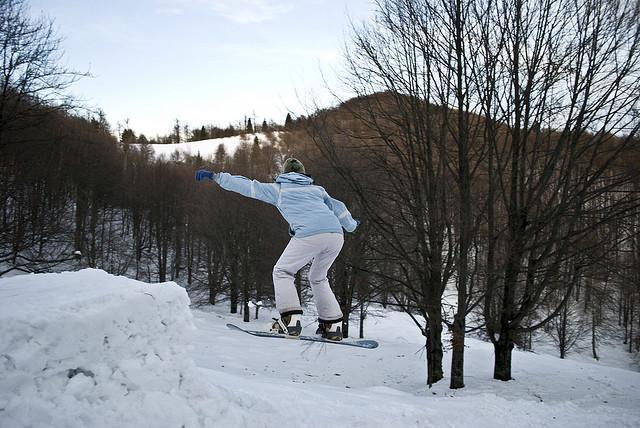How many of the airplanes have entrails?
Give a very brief answer. 0. 